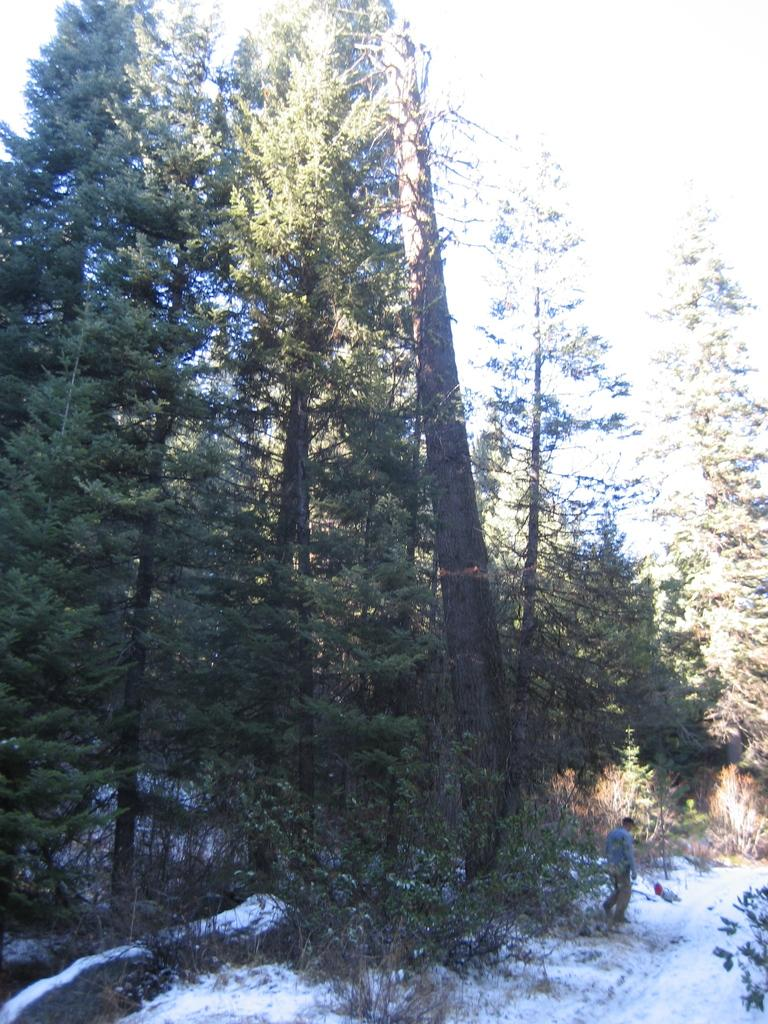What is the person in the image doing? There is a person walking in the image. What type of vegetation can be seen in the image? There are trees in the image. What is visible at the top of the image? The sky is visible at the top of the image. What type of weather is suggested by the presence of snow in the image? The presence of snow at the bottom of the image suggests cold weather. What type of beef can be seen hanging from the trees in the image? There is no beef present in the image; it features a person walking, trees, sky, and snow. 